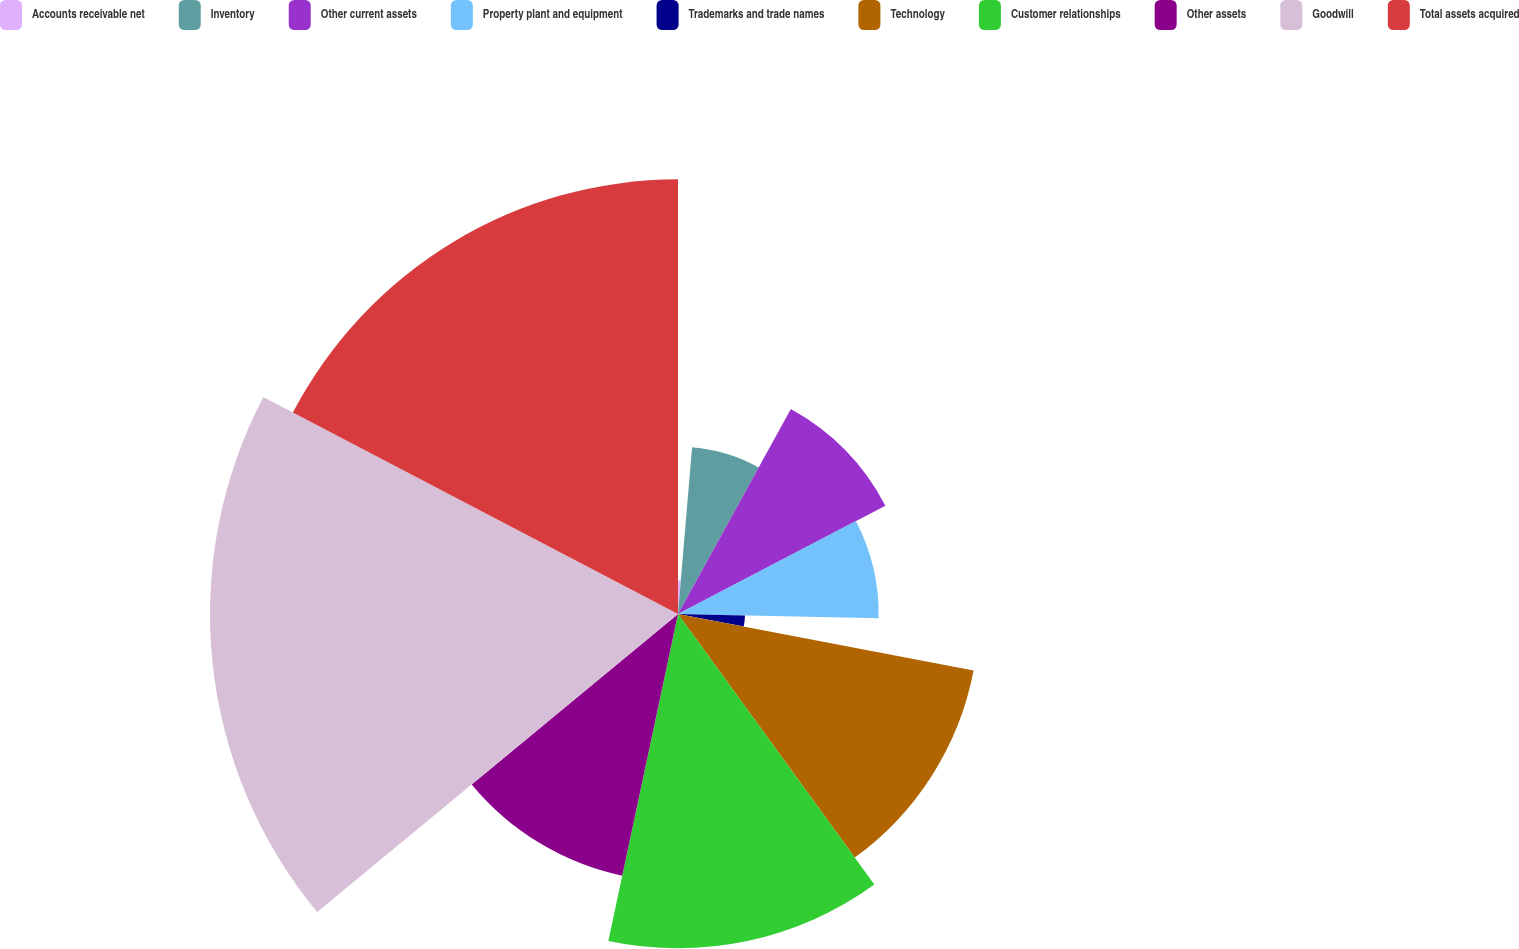Convert chart to OTSL. <chart><loc_0><loc_0><loc_500><loc_500><pie_chart><fcel>Accounts receivable net<fcel>Inventory<fcel>Other current assets<fcel>Property plant and equipment<fcel>Trademarks and trade names<fcel>Technology<fcel>Customer relationships<fcel>Other assets<fcel>Goodwill<fcel>Total assets acquired<nl><fcel>1.34%<fcel>6.67%<fcel>9.33%<fcel>8.0%<fcel>2.67%<fcel>12.0%<fcel>13.33%<fcel>10.67%<fcel>18.66%<fcel>17.33%<nl></chart> 